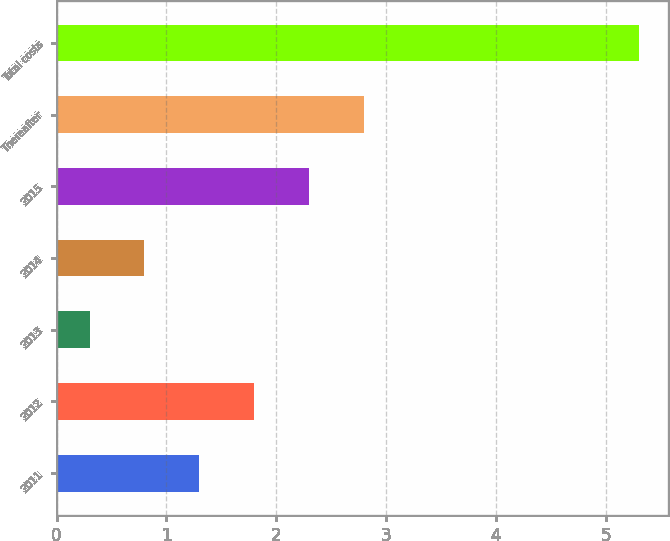Convert chart. <chart><loc_0><loc_0><loc_500><loc_500><bar_chart><fcel>2011<fcel>2012<fcel>2013<fcel>2014<fcel>2015<fcel>Thereafter<fcel>Total costs<nl><fcel>1.3<fcel>1.8<fcel>0.3<fcel>0.8<fcel>2.3<fcel>2.8<fcel>5.3<nl></chart> 